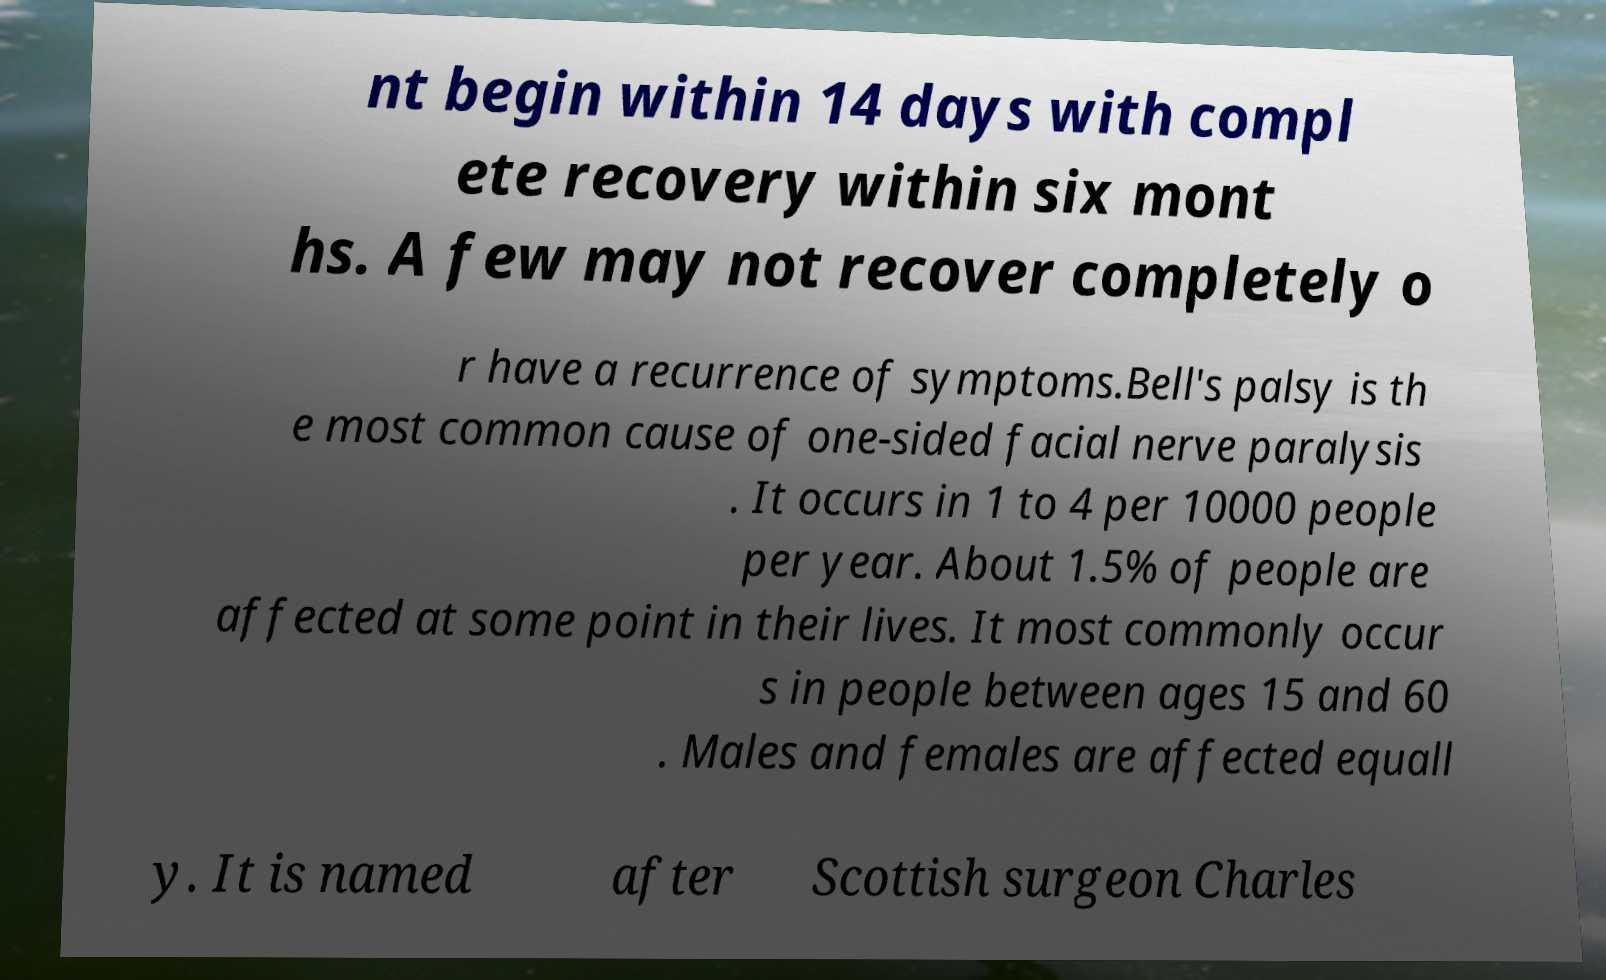I need the written content from this picture converted into text. Can you do that? nt begin within 14 days with compl ete recovery within six mont hs. A few may not recover completely o r have a recurrence of symptoms.Bell's palsy is th e most common cause of one-sided facial nerve paralysis . It occurs in 1 to 4 per 10000 people per year. About 1.5% of people are affected at some point in their lives. It most commonly occur s in people between ages 15 and 60 . Males and females are affected equall y. It is named after Scottish surgeon Charles 